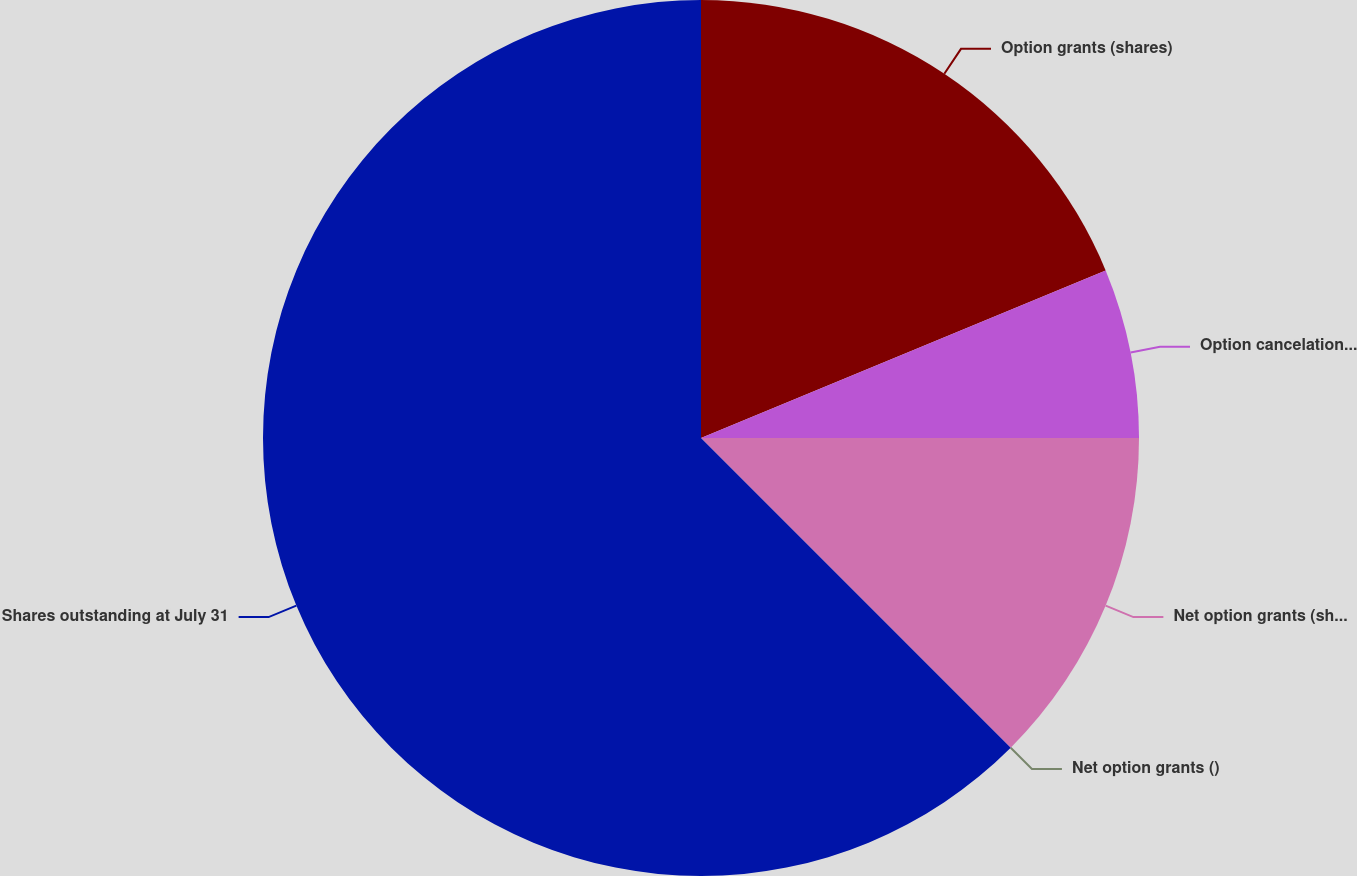Convert chart to OTSL. <chart><loc_0><loc_0><loc_500><loc_500><pie_chart><fcel>Option grants (shares)<fcel>Option cancelations and<fcel>Net option grants (shares)<fcel>Net option grants ()<fcel>Shares outstanding at July 31<nl><fcel>18.75%<fcel>6.25%<fcel>12.5%<fcel>0.0%<fcel>62.5%<nl></chart> 